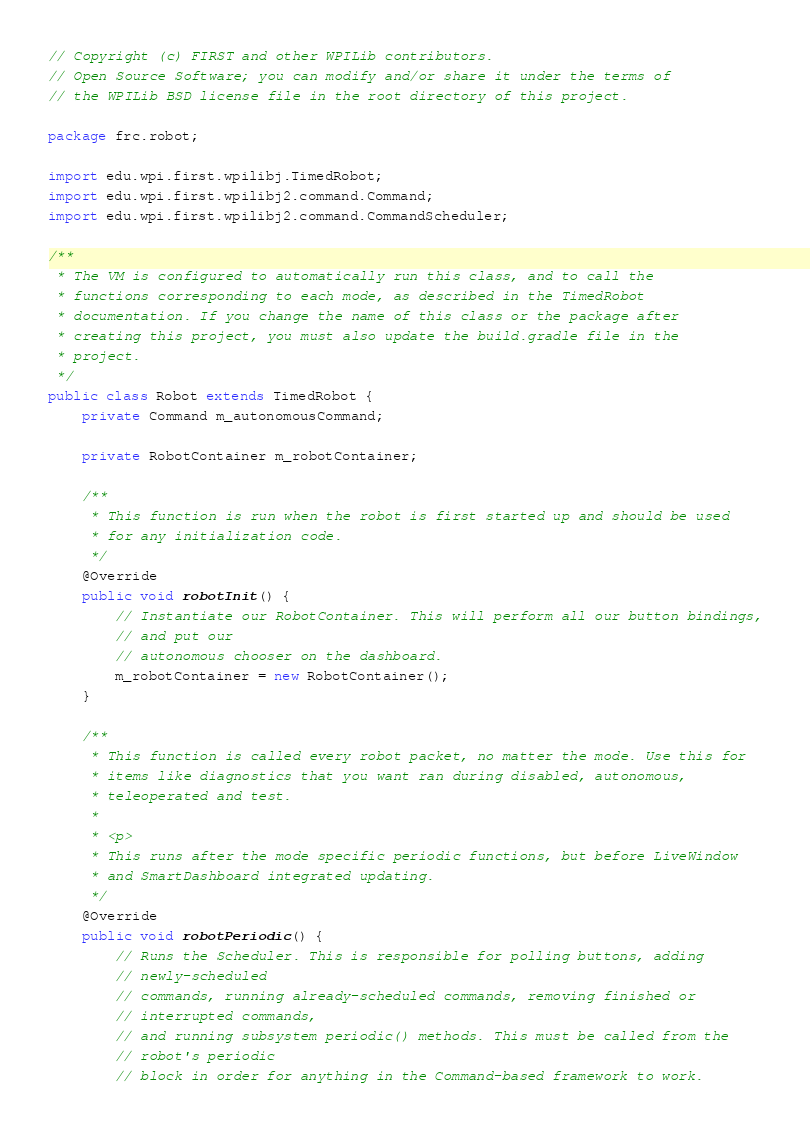Convert code to text. <code><loc_0><loc_0><loc_500><loc_500><_Java_>// Copyright (c) FIRST and other WPILib contributors.
// Open Source Software; you can modify and/or share it under the terms of
// the WPILib BSD license file in the root directory of this project.

package frc.robot;

import edu.wpi.first.wpilibj.TimedRobot;
import edu.wpi.first.wpilibj2.command.Command;
import edu.wpi.first.wpilibj2.command.CommandScheduler;

/**
 * The VM is configured to automatically run this class, and to call the
 * functions corresponding to each mode, as described in the TimedRobot
 * documentation. If you change the name of this class or the package after
 * creating this project, you must also update the build.gradle file in the
 * project.
 */
public class Robot extends TimedRobot {
	private Command m_autonomousCommand;

	private RobotContainer m_robotContainer;

	/**
	 * This function is run when the robot is first started up and should be used
	 * for any initialization code.
	 */
	@Override
	public void robotInit() {
		// Instantiate our RobotContainer. This will perform all our button bindings,
		// and put our
		// autonomous chooser on the dashboard.
		m_robotContainer = new RobotContainer();
	}

	/**
	 * This function is called every robot packet, no matter the mode. Use this for
	 * items like diagnostics that you want ran during disabled, autonomous,
	 * teleoperated and test.
	 *
	 * <p>
	 * This runs after the mode specific periodic functions, but before LiveWindow
	 * and SmartDashboard integrated updating.
	 */
	@Override
	public void robotPeriodic() {
		// Runs the Scheduler. This is responsible for polling buttons, adding
		// newly-scheduled
		// commands, running already-scheduled commands, removing finished or
		// interrupted commands,
		// and running subsystem periodic() methods. This must be called from the
		// robot's periodic
		// block in order for anything in the Command-based framework to work.</code> 